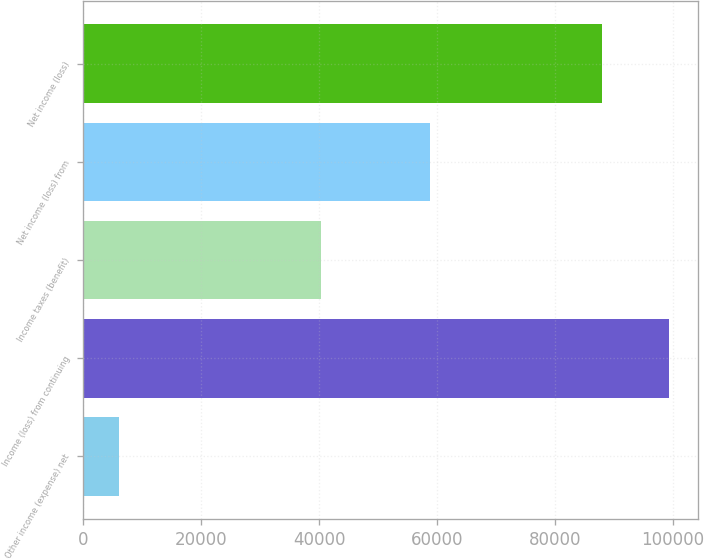Convert chart. <chart><loc_0><loc_0><loc_500><loc_500><bar_chart><fcel>Other income (expense) net<fcel>Income (loss) from continuing<fcel>Income taxes (benefit)<fcel>Net income (loss) from<fcel>Net income (loss)<nl><fcel>5992<fcel>99253<fcel>40386<fcel>58867<fcel>88043<nl></chart> 